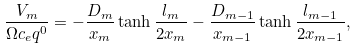<formula> <loc_0><loc_0><loc_500><loc_500>\frac { V _ { m } } { \Omega c _ { e } q ^ { 0 } } = - \frac { D _ { m } } { x _ { m } } \tanh \frac { l _ { m } } { 2 x _ { m } } - \frac { D _ { m - 1 } } { x _ { m - 1 } } \tanh \frac { l _ { m - 1 } } { 2 x _ { m - 1 } } ,</formula> 